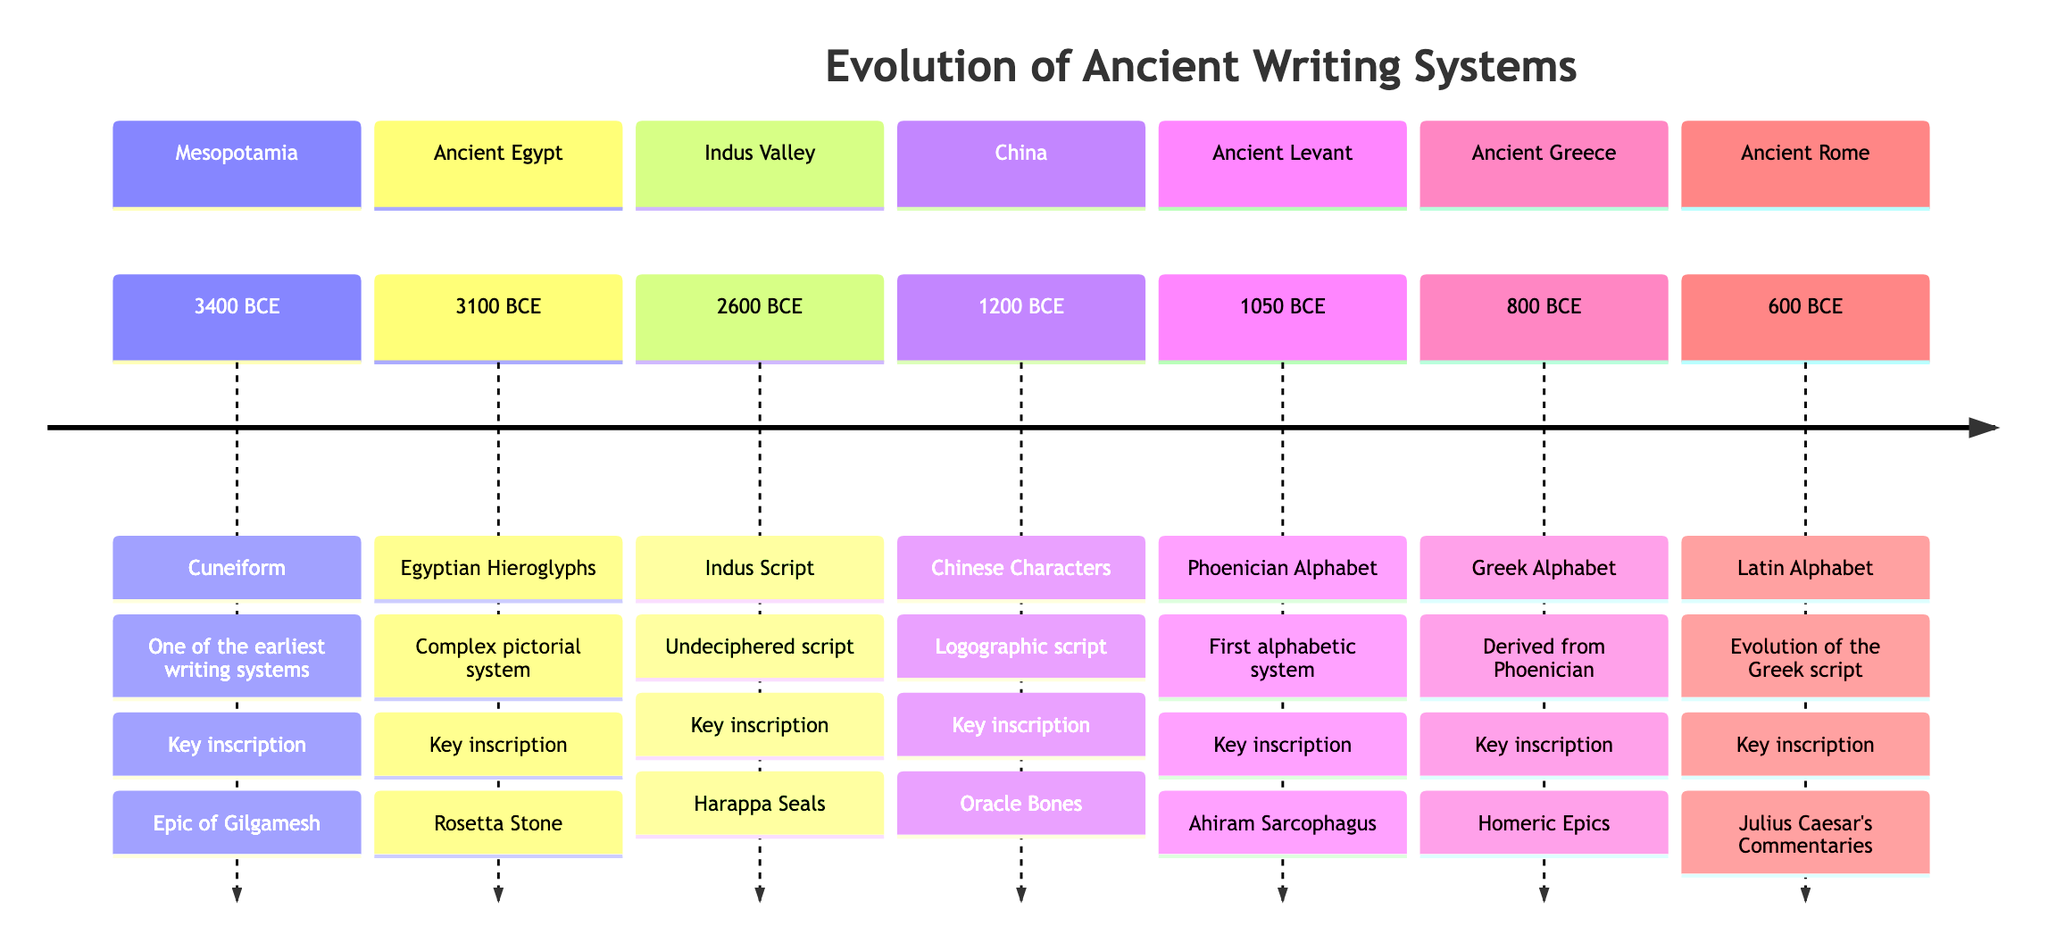What is the earliest writing system shown in the diagram? The diagram indicates that Cuneiform is the earliest writing system, dating back to 3400 BCE under the Mesopotamia section.
Answer: Cuneiform What key inscription is associated with the Egyptian Hieroglyphs? The diagram specifies that the key inscription linked to Egyptian Hieroglyphs is the Rosetta Stone, which is noted in the Ancient Egypt section.
Answer: Rosetta Stone Which civilization first developed an alphabetic system? The diagram reveals that the Phoenician Alphabet, developed in the Ancient Levant in 1050 BCE, is recognized as the first alphabetic system.
Answer: Phoenician Alphabet What is the date range for the Indus Script? The diagram clearly identifies that the Indus Script dates back to 2600 BCE, as specified in the Indus Valley section, making it straightforward to find in the timeline.
Answer: 2600 BCE How is the Greek Alphabet related to the Phoenician system? According to the diagram, the Greek Alphabet is derived from the Phoenician, as stated in the Ancient Greece section. This indicates a direct lineage from one system to another.
Answer: Derived from Phoenician Which writing system evolved from the Greek script? The diagram indicates that the Latin Alphabet evolved from the Greek script, as shown in the Ancient Rome section. This establishes a historical progression of writing systems.
Answer: Latin Alphabet What is the most recent writing system represented in the diagram? By examining the timeline, we can see that the most recent writing system represented is the Latin Alphabet from 600 BCE in the Ancient Rome section, making it the latest of the listed systems.
Answer: Latin Alphabet Which inscription is linked to Chinese Characters? The diagram states that the key inscription associated with Chinese Characters is the Oracle Bones, which is highlighted in the China section. This identifies the significance of this writing form.
Answer: Oracle Bones What does the timeline show about the progression of writing systems over time? The diagram illustrates a chronological progression from Cuneiform in 3400 BCE to the Latin Alphabet in 600 BCE, demonstrating how writing systems evolved over several millennia. This shows how ancient civility adapted their communication methods.
Answer: Chronological progression 